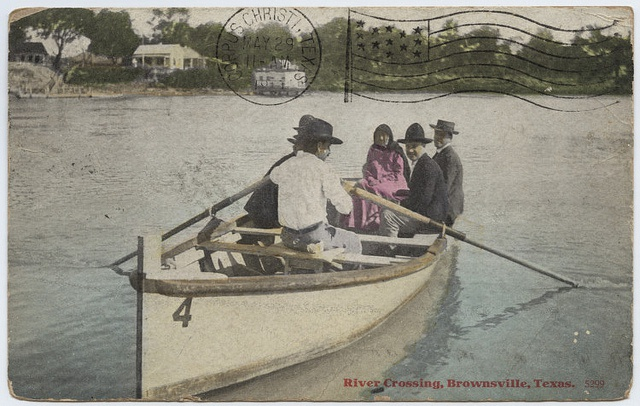Describe the objects in this image and their specific colors. I can see boat in lightgray, darkgray, gray, and tan tones, people in lightgray, darkgray, and gray tones, people in lightgray, gray, black, and darkgray tones, people in lightgray, gray, and darkgray tones, and people in lightgray, black, gray, and darkgray tones in this image. 